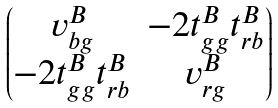<formula> <loc_0><loc_0><loc_500><loc_500>\begin{pmatrix} v ^ { B } _ { b g } & - 2 t ^ { B } _ { g g } t ^ { B } _ { r b } \\ - 2 t ^ { B } _ { g g } t ^ { B } _ { r b } & v ^ { B } _ { r g } \end{pmatrix}</formula> 